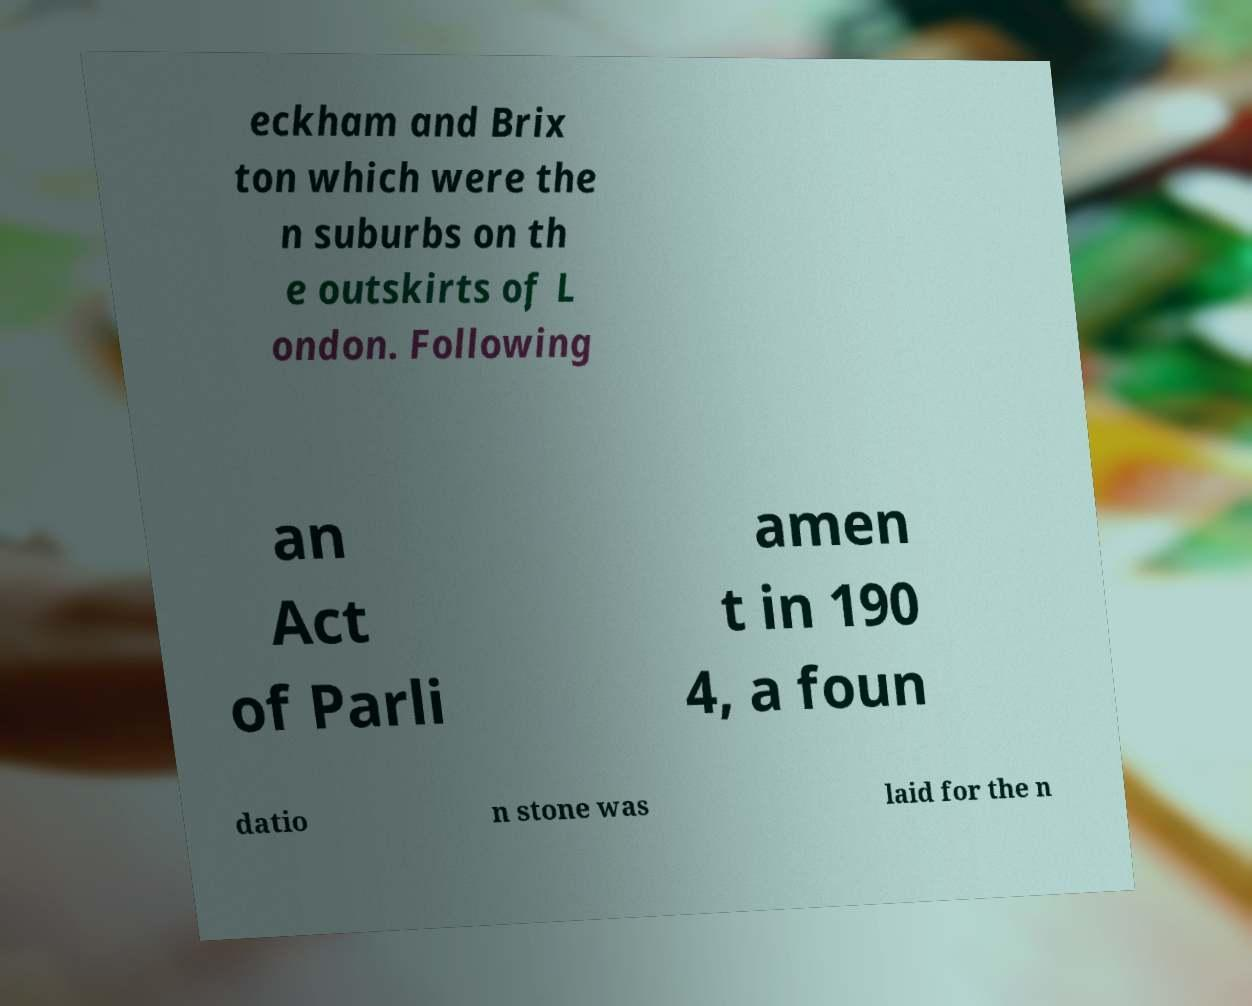Could you assist in decoding the text presented in this image and type it out clearly? eckham and Brix ton which were the n suburbs on th e outskirts of L ondon. Following an Act of Parli amen t in 190 4, a foun datio n stone was laid for the n 